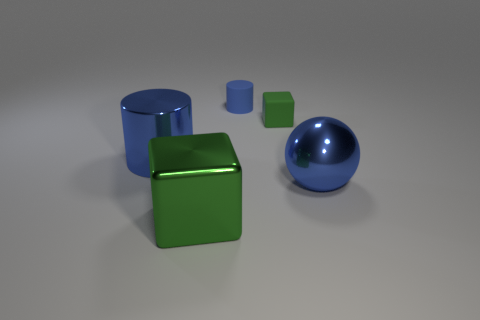What is the shape of the large blue thing that is behind the big thing that is on the right side of the green cube that is behind the shiny cube?
Make the answer very short. Cylinder. There is a large blue metal cylinder; what number of large green metal things are on the right side of it?
Provide a short and direct response. 1. Is the material of the cylinder that is behind the rubber cube the same as the big cylinder?
Your answer should be very brief. No. What number of small things are to the right of the cylinder behind the shiny object behind the big ball?
Ensure brevity in your answer.  1. The large object that is behind the blue metal ball is what color?
Make the answer very short. Blue. Is the color of the shiny object that is right of the large green object the same as the shiny block?
Keep it short and to the point. No. What size is the green shiny object that is the same shape as the small green rubber thing?
Offer a terse response. Large. Is there anything else that has the same size as the blue metallic cylinder?
Your answer should be compact. Yes. What material is the green cube behind the big shiny object to the right of the small rubber object behind the tiny green rubber block?
Provide a short and direct response. Rubber. Is the number of things that are behind the large green shiny cube greater than the number of metal balls behind the small blue rubber cylinder?
Your response must be concise. Yes. 